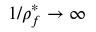<formula> <loc_0><loc_0><loc_500><loc_500>1 / \rho _ { f } ^ { * } \rightarrow \infty</formula> 